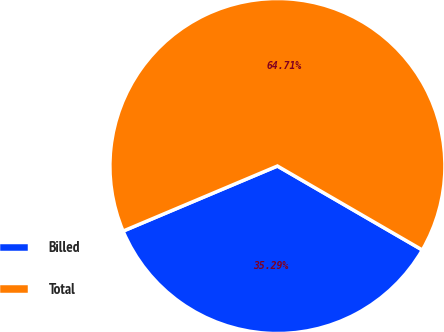Convert chart. <chart><loc_0><loc_0><loc_500><loc_500><pie_chart><fcel>Billed<fcel>Total<nl><fcel>35.29%<fcel>64.71%<nl></chart> 